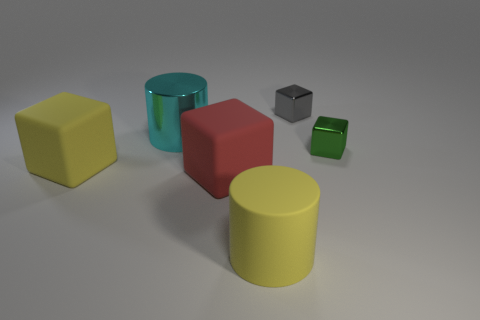Add 1 large red metal cylinders. How many objects exist? 7 Subtract all cubes. How many objects are left? 2 Subtract all metal objects. Subtract all yellow cylinders. How many objects are left? 2 Add 1 yellow things. How many yellow things are left? 3 Add 2 small blocks. How many small blocks exist? 4 Subtract 0 gray cylinders. How many objects are left? 6 